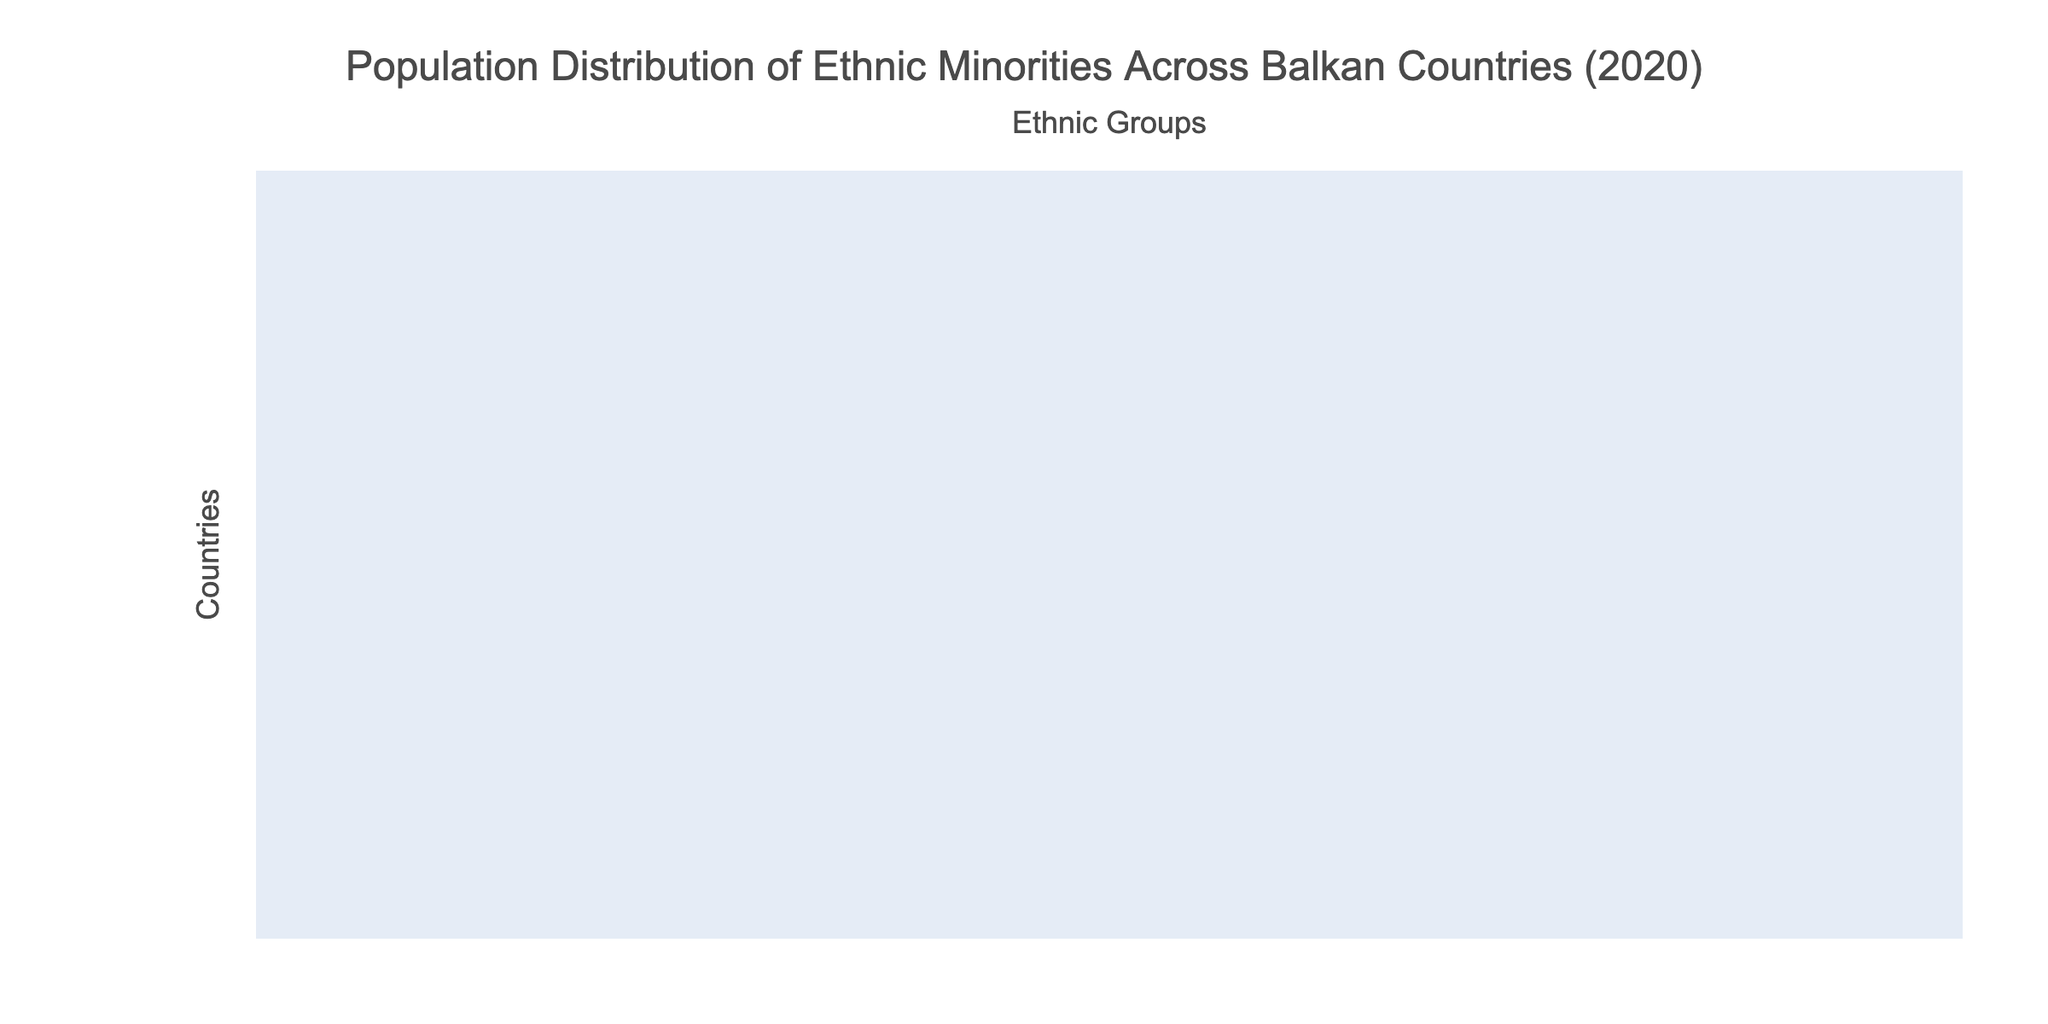What is the percentage of ethnic Albanians in North Macedonia? The table indicates that the percentage of ethnic Albanians in North Macedonia is 25.17%.
Answer: 25.17% Which country has the highest percentage of Bulgarian minorities? According to the table, Bulgaria has the highest percentage of Bulgarian minorities at 84.80%.
Answer: 84.80% Is the percentage of Roma in Serbia higher than in Croatia? The table shows that Serbia has 2.05% Roma while Croatia has 0.40%, which means the percentage in Serbia is higher.
Answer: Yes What are the combined percentages of ethnic Greeks in Greece and North Macedonia? In Greece, the percentage of ethnic Greeks is 93.00%, while in North Macedonia it is 0.02%. Adding these gives a total of 93.02%.
Answer: 93.02% Which country has the lowest representation of Vlach minorities? The lowest representation of Vlach minorities is found in both Greece and Bulgaria, where it is 0.01%.
Answer: Greece and Bulgaria What is the total percentage of ethnic Macedonians in North Macedonia compared to Kosovo? North Macedonia has 64.18% ethnic Macedonians, while Kosovo has 1.58%. The difference is 64.18% - 1.58% = 62.60%.
Answer: 62.60% Which ethnic group has the largest population in Kosovo? The table indicates that the largest ethnic group in Kosovo is the Albanians, at 92.93%.
Answer: 92.93% How does the percentage of Turks in Bulgaria compare to that in Serbia? Bulgaria has 8.80% Turks while Serbia only has 0.01%, which shows a significant difference of 8.79% more in Bulgaria.
Answer: 8.79% more in Bulgaria What is the average percentage of Bosniaks across all countries listed? The Bosniak percentages from all countries are: Serbia (2.02%), North Macedonia (0.87%), Greece (0.01%), Bulgaria (0.01%), Montenegro (8.65%), Kosovo (1.58%), Bosnia and Herzegovina (50.11%), Croatia (0.73%), Slovenia (1.72%). The sum is 65.70% and there are 9 countries, so the average is 65.70% / 9 = 7.30%.
Answer: 7.30% Are there any countries with no representation of ethnic Greeks? The table shows that in countries other than Greece, there is no percentage listed for ethnic Greeks, indicating that they are not represented in those countries.
Answer: Yes 